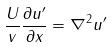Convert formula to latex. <formula><loc_0><loc_0><loc_500><loc_500>\frac { U } { v } \frac { \partial u ^ { \prime } } { \partial x } = \nabla ^ { 2 } u ^ { \prime }</formula> 